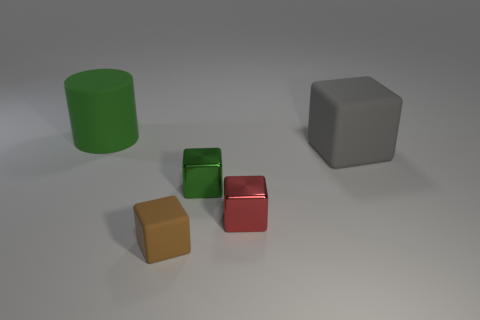Subtract all green cubes. How many cubes are left? 3 Add 4 large things. How many objects exist? 9 Subtract 2 cubes. How many cubes are left? 2 Subtract all cyan cubes. Subtract all gray cylinders. How many cubes are left? 4 Subtract all blocks. How many objects are left? 1 Subtract all blocks. Subtract all gray cubes. How many objects are left? 0 Add 2 matte blocks. How many matte blocks are left? 4 Add 1 large green cylinders. How many large green cylinders exist? 2 Subtract 0 yellow cylinders. How many objects are left? 5 